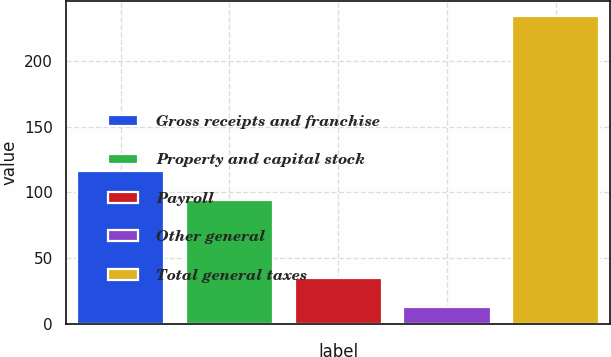Convert chart to OTSL. <chart><loc_0><loc_0><loc_500><loc_500><bar_chart><fcel>Gross receipts and franchise<fcel>Property and capital stock<fcel>Payroll<fcel>Other general<fcel>Total general taxes<nl><fcel>116.1<fcel>94<fcel>35.1<fcel>13<fcel>234<nl></chart> 